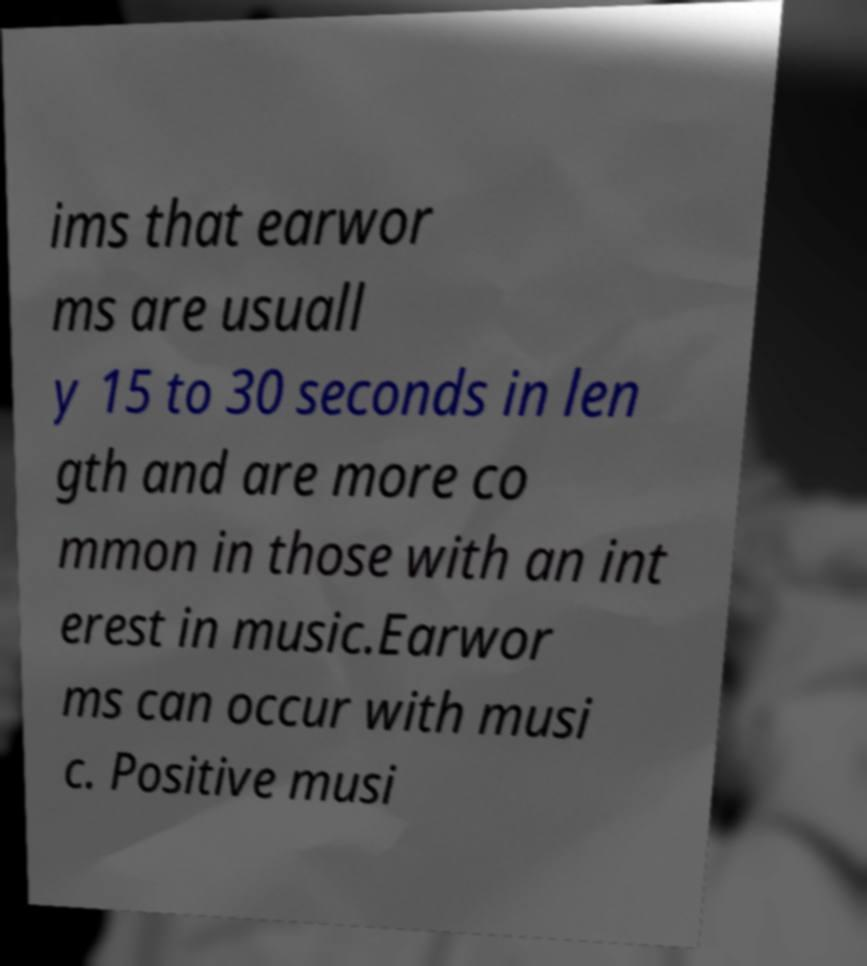Could you extract and type out the text from this image? ims that earwor ms are usuall y 15 to 30 seconds in len gth and are more co mmon in those with an int erest in music.Earwor ms can occur with musi c. Positive musi 